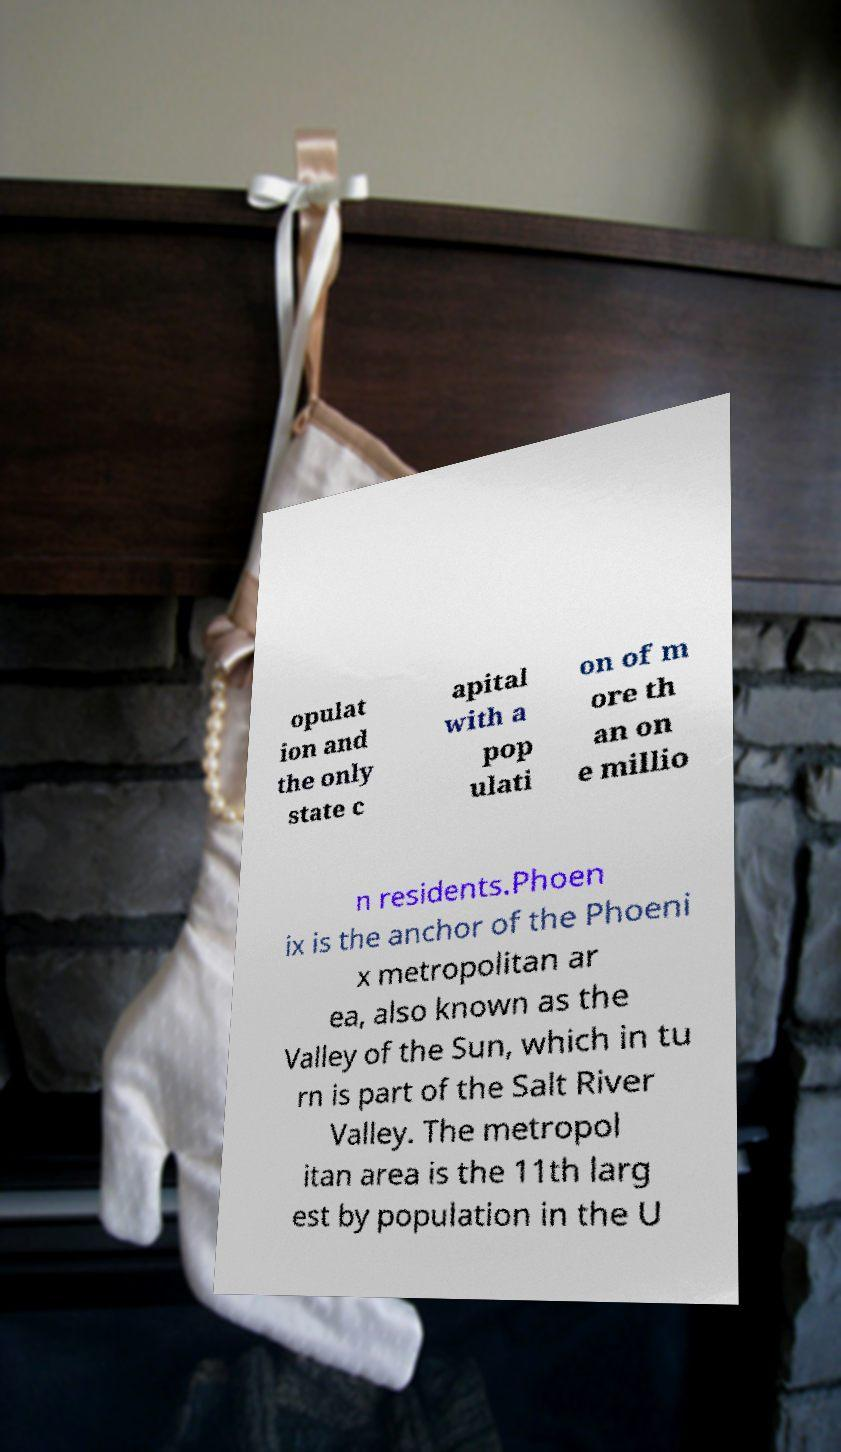What messages or text are displayed in this image? I need them in a readable, typed format. opulat ion and the only state c apital with a pop ulati on of m ore th an on e millio n residents.Phoen ix is the anchor of the Phoeni x metropolitan ar ea, also known as the Valley of the Sun, which in tu rn is part of the Salt River Valley. The metropol itan area is the 11th larg est by population in the U 